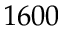Convert formula to latex. <formula><loc_0><loc_0><loc_500><loc_500>1 6 0 0</formula> 